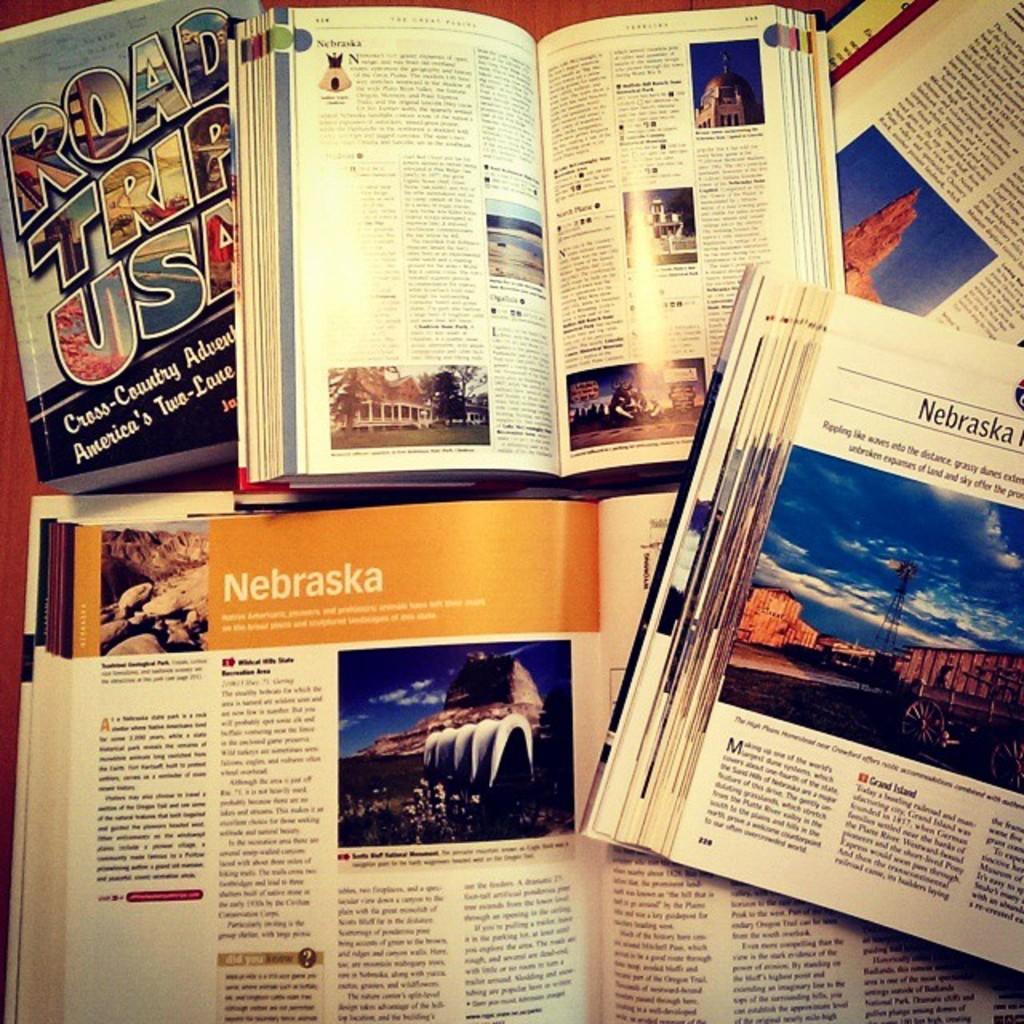Is this person planning a road trip to nebraska?
Your answer should be very brief. Yes. 